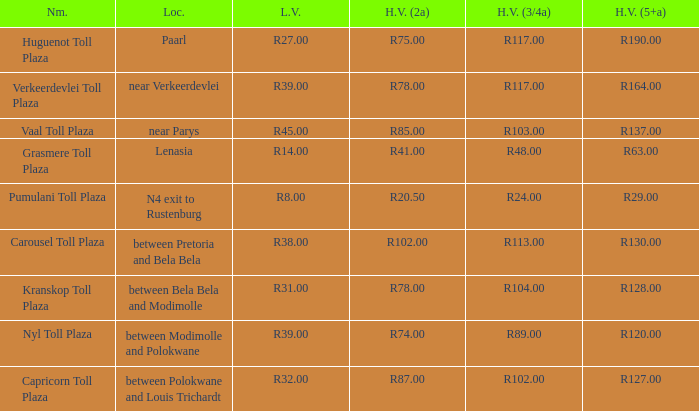What is the location of the Carousel toll plaza? Between pretoria and bela bela. 